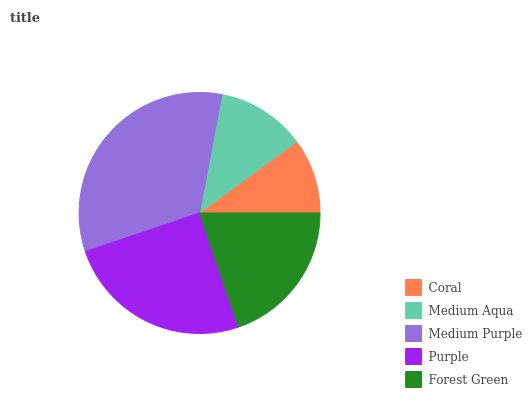Is Coral the minimum?
Answer yes or no. Yes. Is Medium Purple the maximum?
Answer yes or no. Yes. Is Medium Aqua the minimum?
Answer yes or no. No. Is Medium Aqua the maximum?
Answer yes or no. No. Is Medium Aqua greater than Coral?
Answer yes or no. Yes. Is Coral less than Medium Aqua?
Answer yes or no. Yes. Is Coral greater than Medium Aqua?
Answer yes or no. No. Is Medium Aqua less than Coral?
Answer yes or no. No. Is Forest Green the high median?
Answer yes or no. Yes. Is Forest Green the low median?
Answer yes or no. Yes. Is Purple the high median?
Answer yes or no. No. Is Medium Aqua the low median?
Answer yes or no. No. 